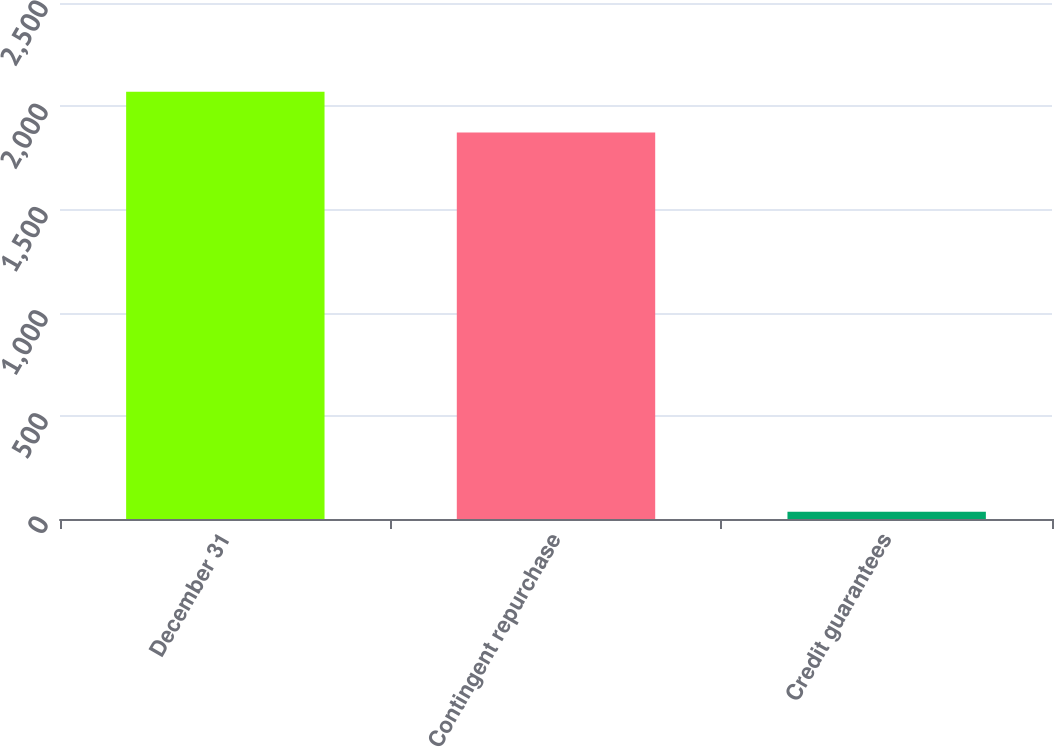Convert chart to OTSL. <chart><loc_0><loc_0><loc_500><loc_500><bar_chart><fcel>December 31<fcel>Contingent repurchase<fcel>Credit guarantees<nl><fcel>2069.8<fcel>1872<fcel>35<nl></chart> 